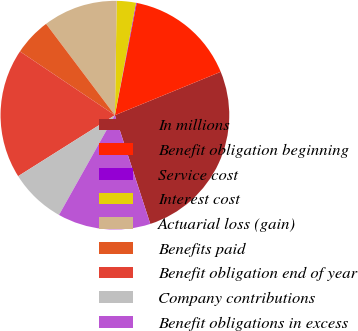<chart> <loc_0><loc_0><loc_500><loc_500><pie_chart><fcel>In millions<fcel>Benefit obligation beginning<fcel>Service cost<fcel>Interest cost<fcel>Actuarial loss (gain)<fcel>Benefits paid<fcel>Benefit obligation end of year<fcel>Company contributions<fcel>Benefit obligations in excess<nl><fcel>26.18%<fcel>15.75%<fcel>0.1%<fcel>2.71%<fcel>10.53%<fcel>5.31%<fcel>18.36%<fcel>7.92%<fcel>13.14%<nl></chart> 